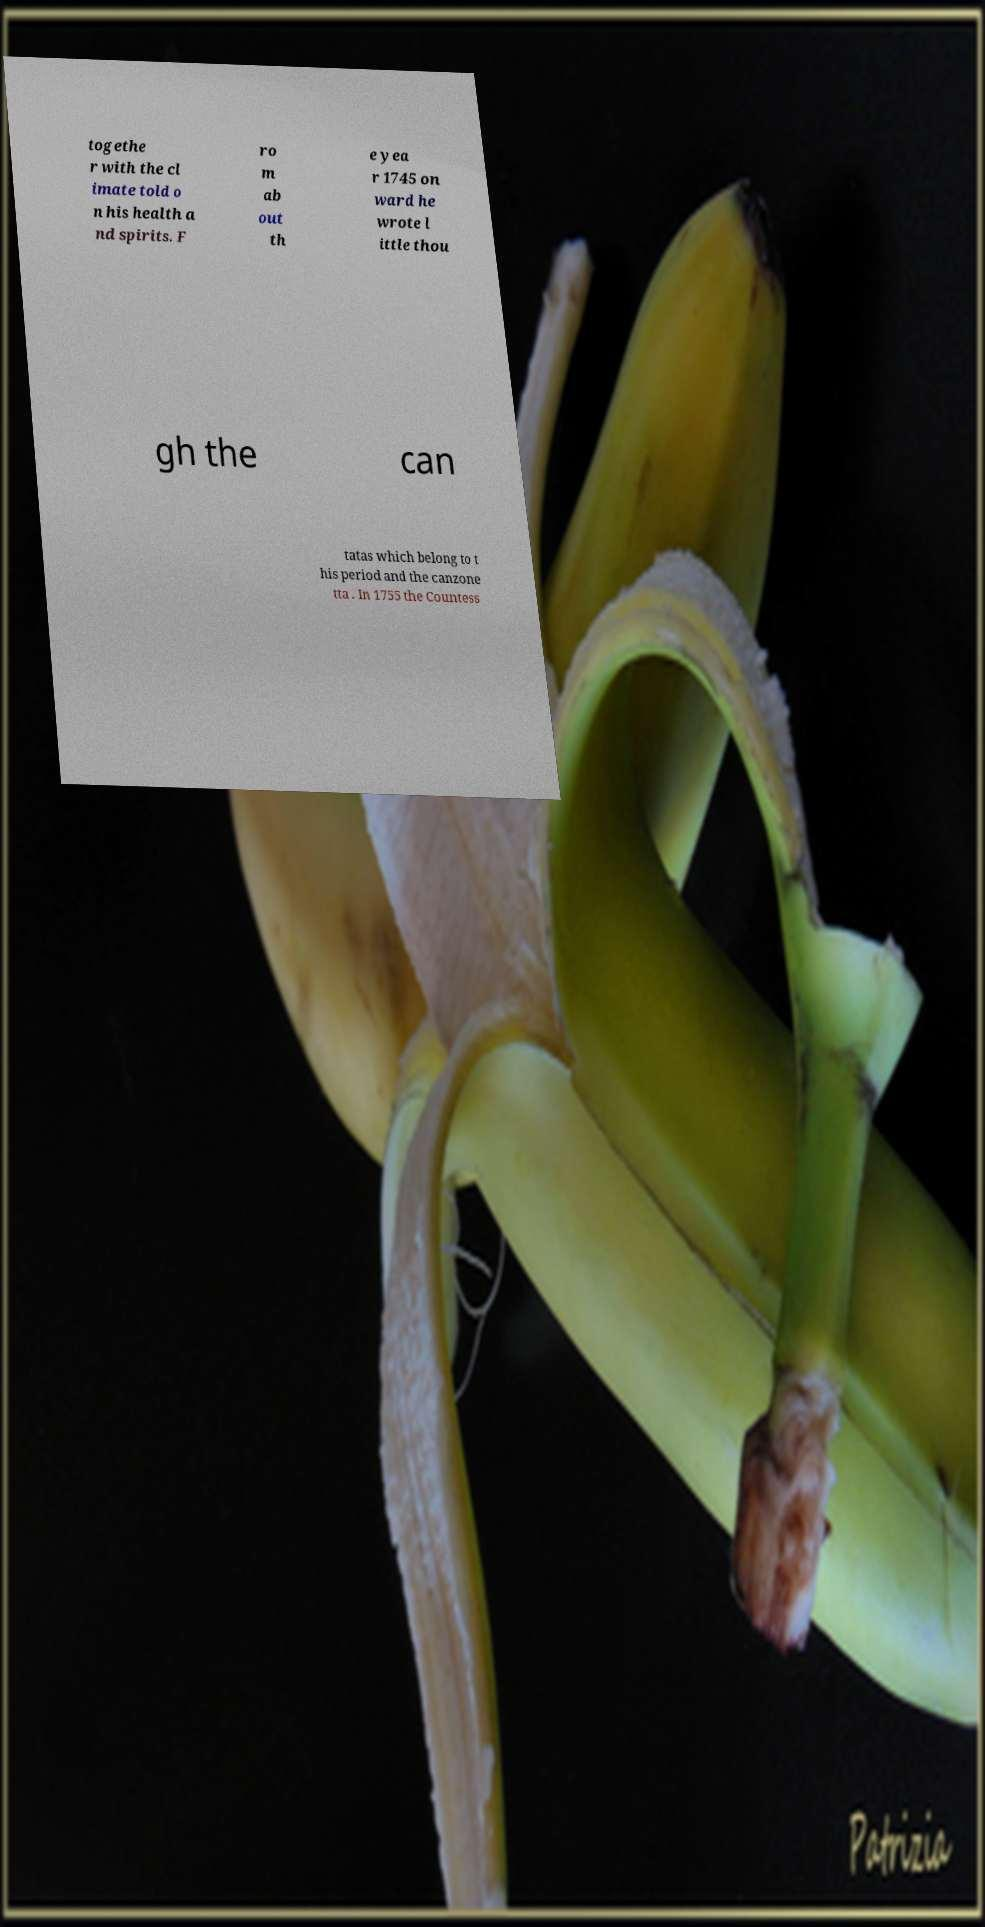Can you accurately transcribe the text from the provided image for me? togethe r with the cl imate told o n his health a nd spirits. F ro m ab out th e yea r 1745 on ward he wrote l ittle thou gh the can tatas which belong to t his period and the canzone tta . In 1755 the Countess 